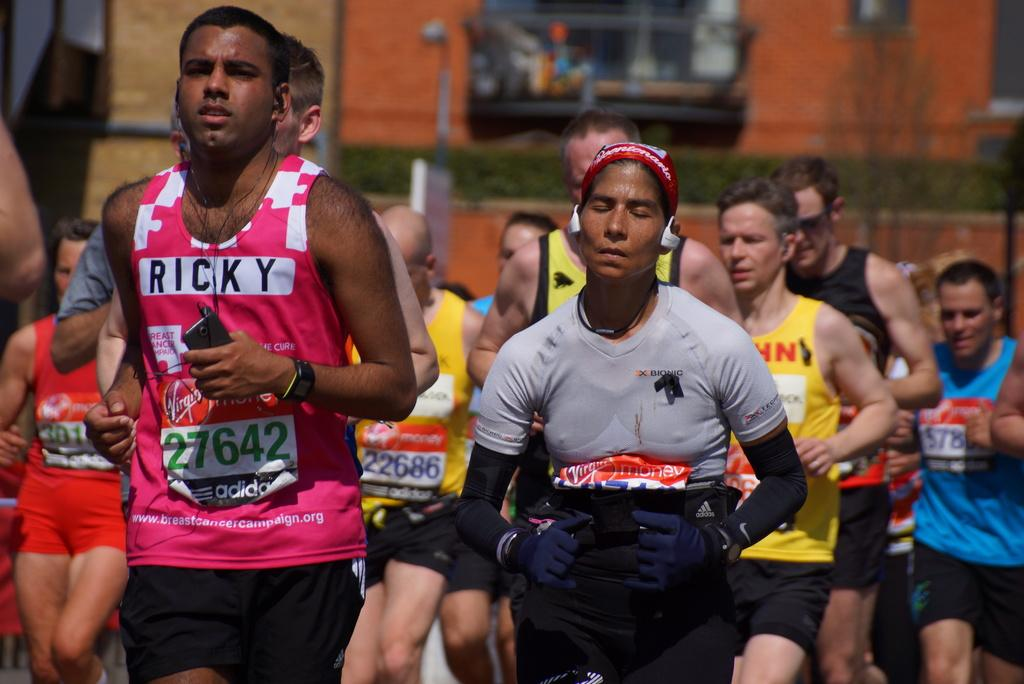What are the persons in the image doing? The persons in the image are running. What can be seen in the background of the image? There is a building in the background of the image. What note is being played by the toe in the image? There is no musical note or toe playing an instrument in the image; it features persons running and a building in the background. 